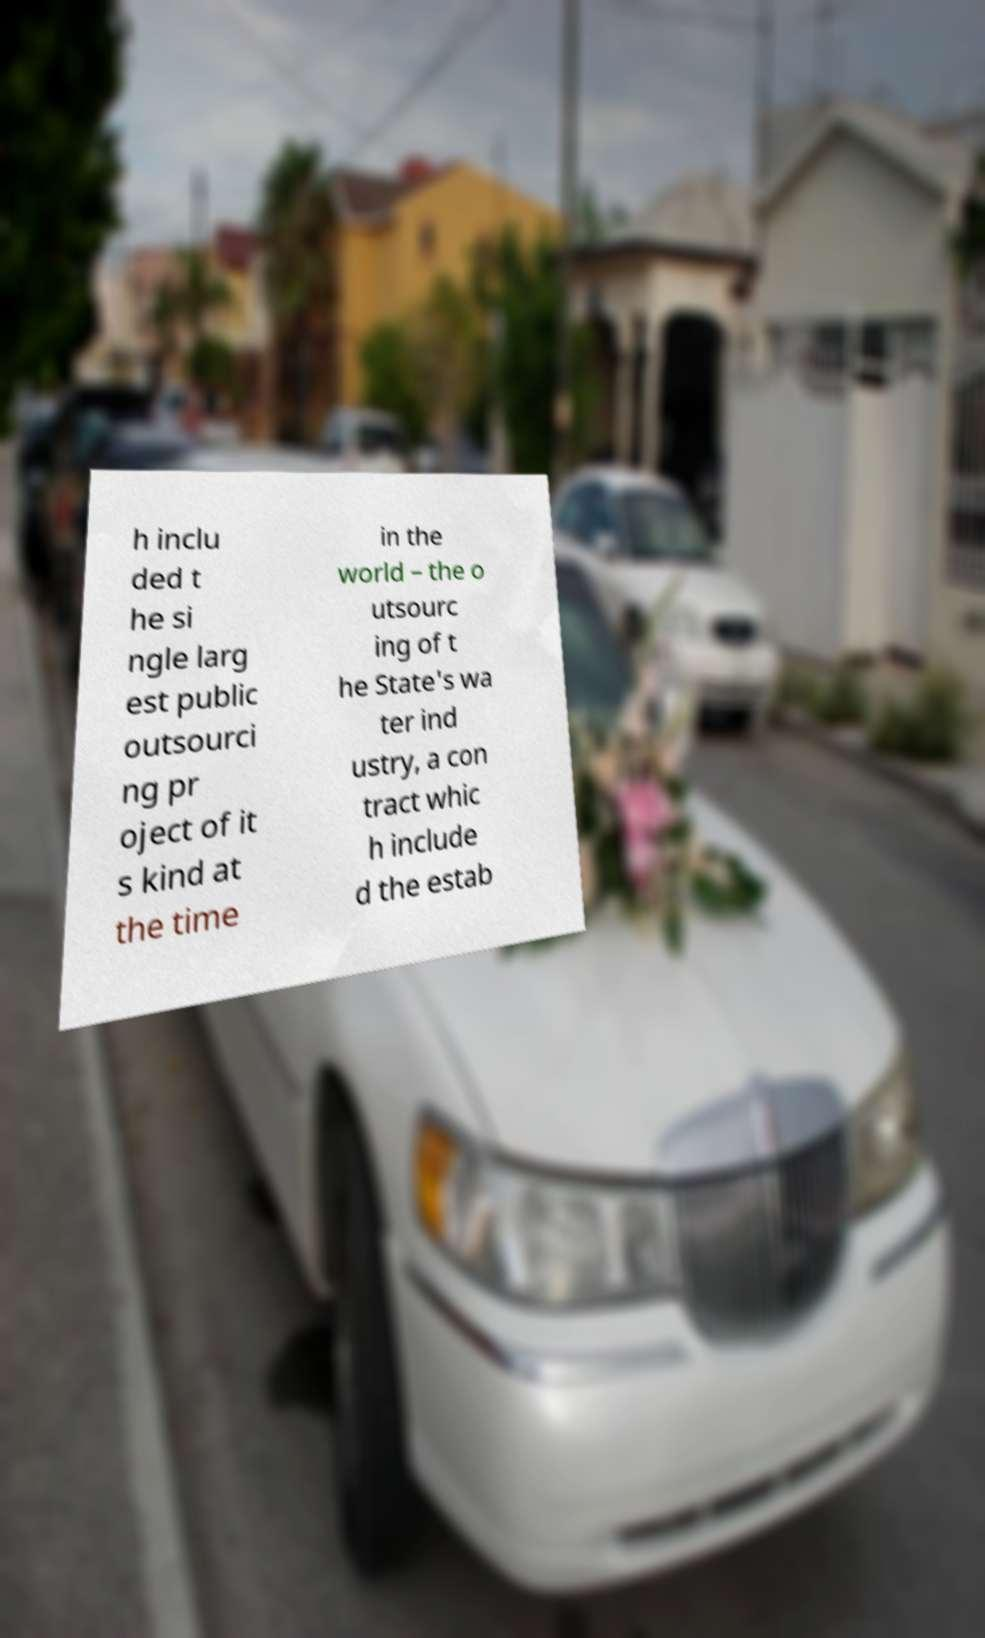Can you read and provide the text displayed in the image?This photo seems to have some interesting text. Can you extract and type it out for me? h inclu ded t he si ngle larg est public outsourci ng pr oject of it s kind at the time in the world – the o utsourc ing of t he State's wa ter ind ustry, a con tract whic h include d the estab 